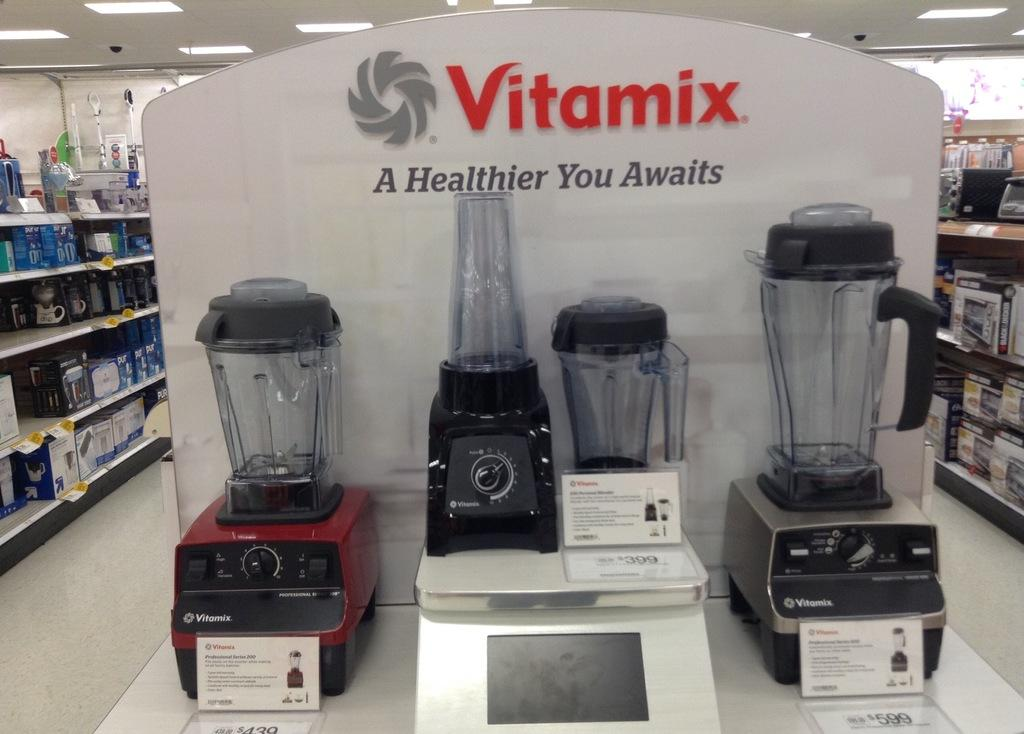Provide a one-sentence caption for the provided image. A display of Vitamix blenders sits on an end display in a store. 